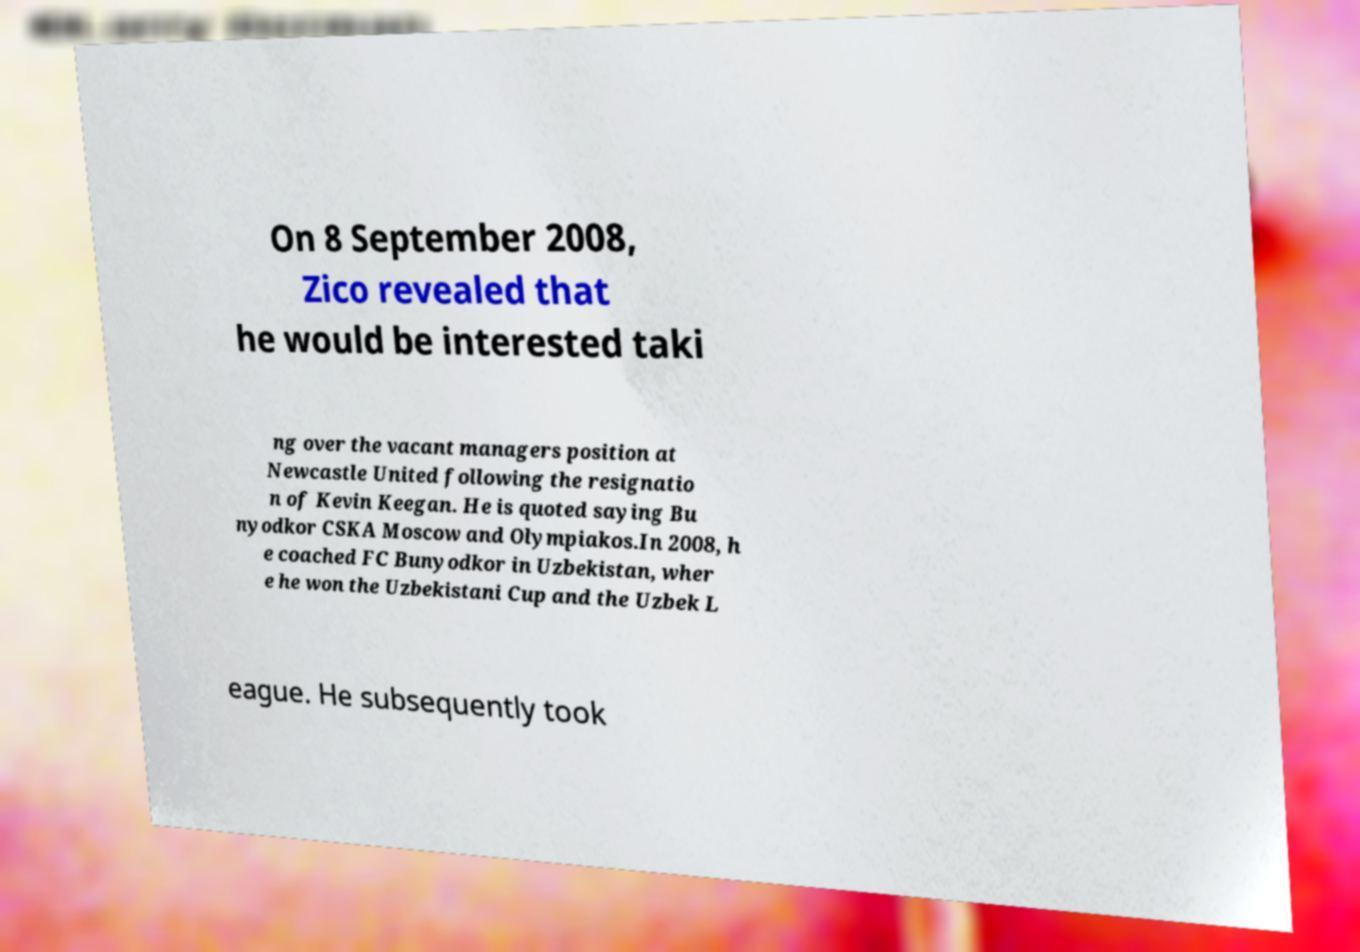What messages or text are displayed in this image? I need them in a readable, typed format. On 8 September 2008, Zico revealed that he would be interested taki ng over the vacant managers position at Newcastle United following the resignatio n of Kevin Keegan. He is quoted saying Bu nyodkor CSKA Moscow and Olympiakos.In 2008, h e coached FC Bunyodkor in Uzbekistan, wher e he won the Uzbekistani Cup and the Uzbek L eague. He subsequently took 